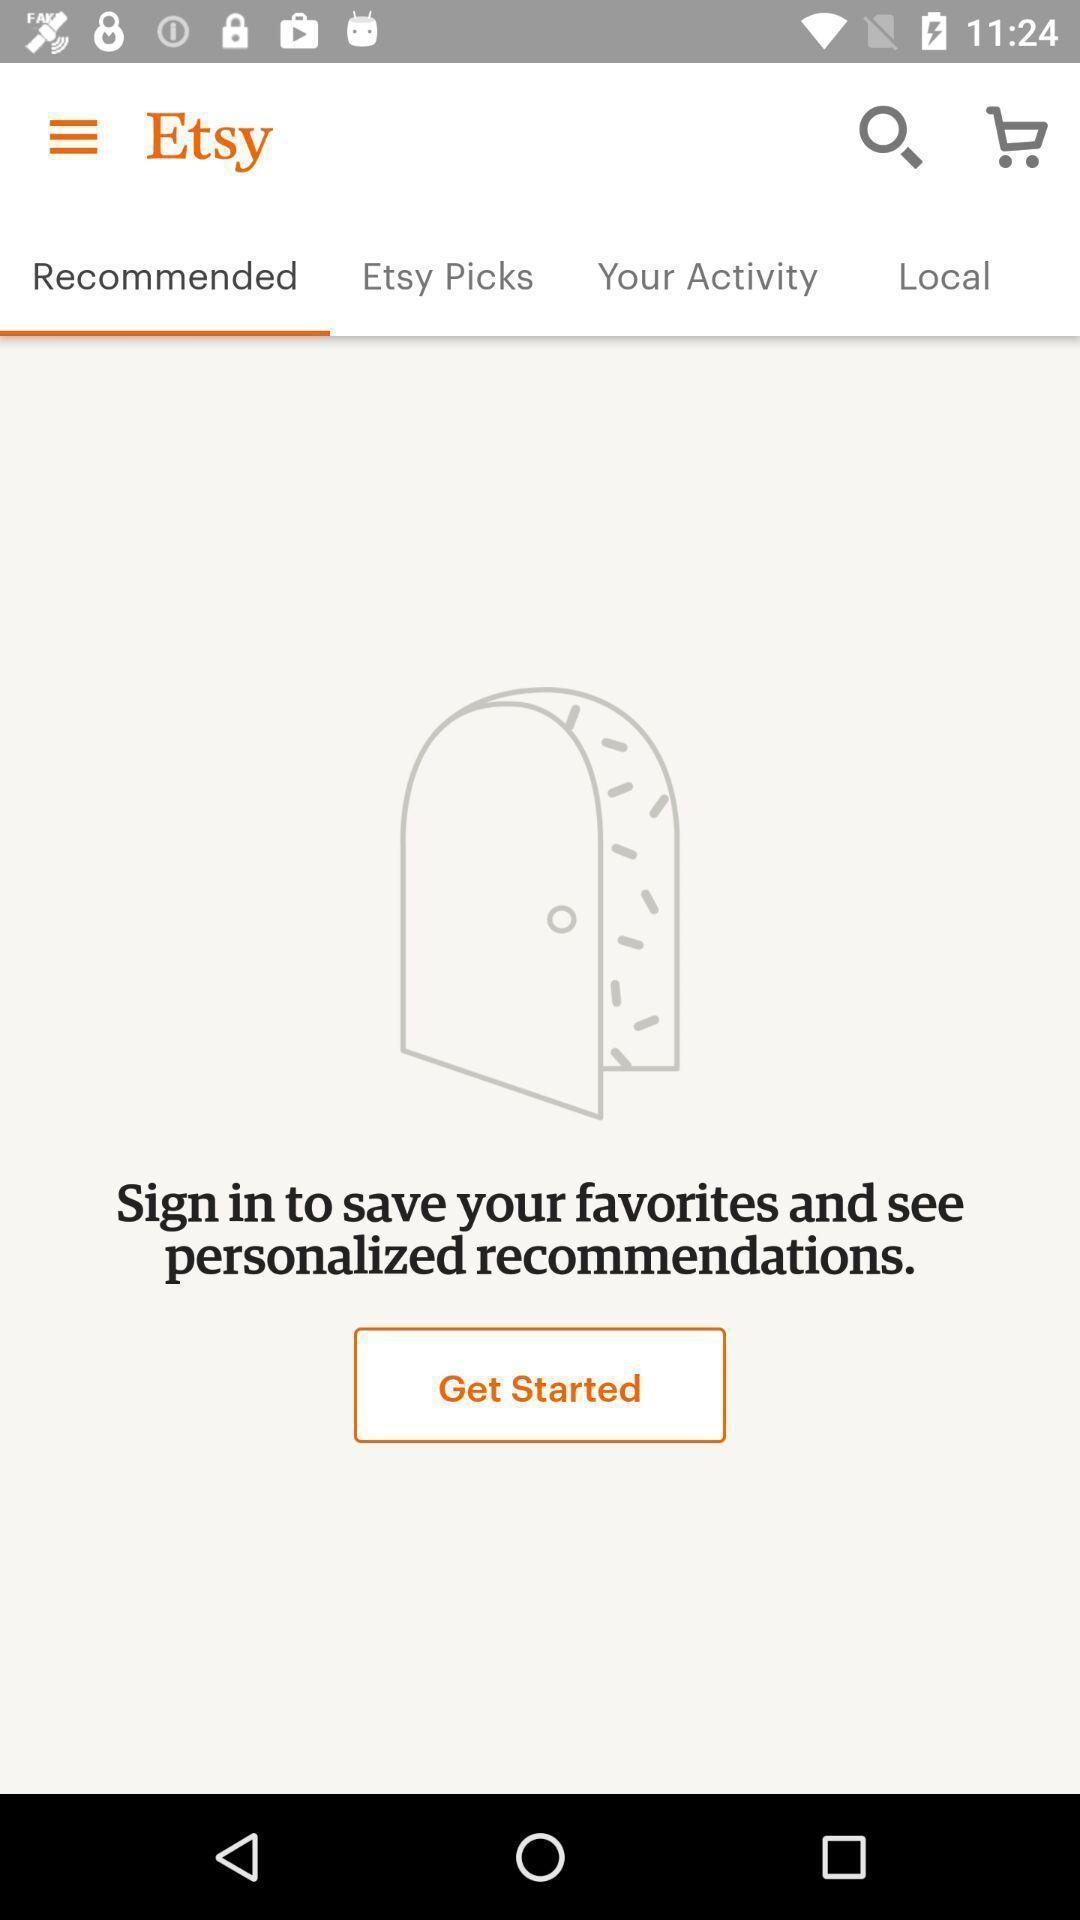What details can you identify in this image? Screen displaying recommended page. 